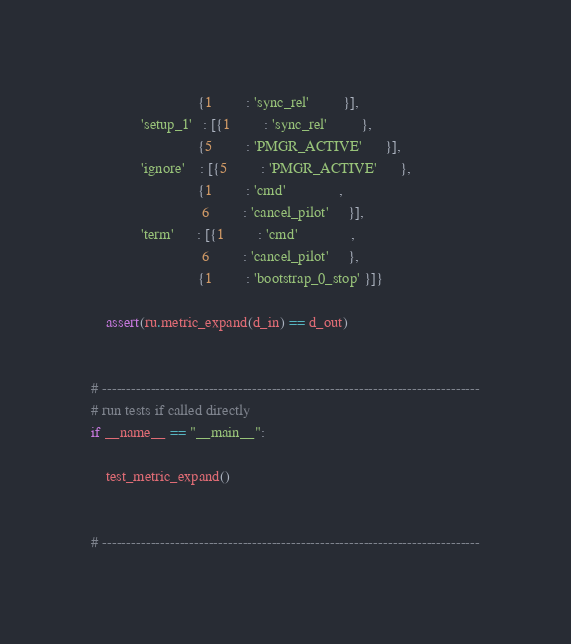<code> <loc_0><loc_0><loc_500><loc_500><_Python_>                            {1         : 'sync_rel'         }],
             'setup_1'   : [{1         : 'sync_rel'         },
                            {5         : 'PMGR_ACTIVE'      }],
             'ignore'    : [{5         : 'PMGR_ACTIVE'      },
                            {1         : 'cmd'              ,
                             6         : 'cancel_pilot'     }],
             'term'      : [{1         : 'cmd'              ,
                             6         : 'cancel_pilot'     },
                            {1         : 'bootstrap_0_stop' }]}

    assert(ru.metric_expand(d_in) == d_out)


# ------------------------------------------------------------------------------
# run tests if called directly
if __name__ == "__main__":

    test_metric_expand()


# ------------------------------------------------------------------------------

</code> 